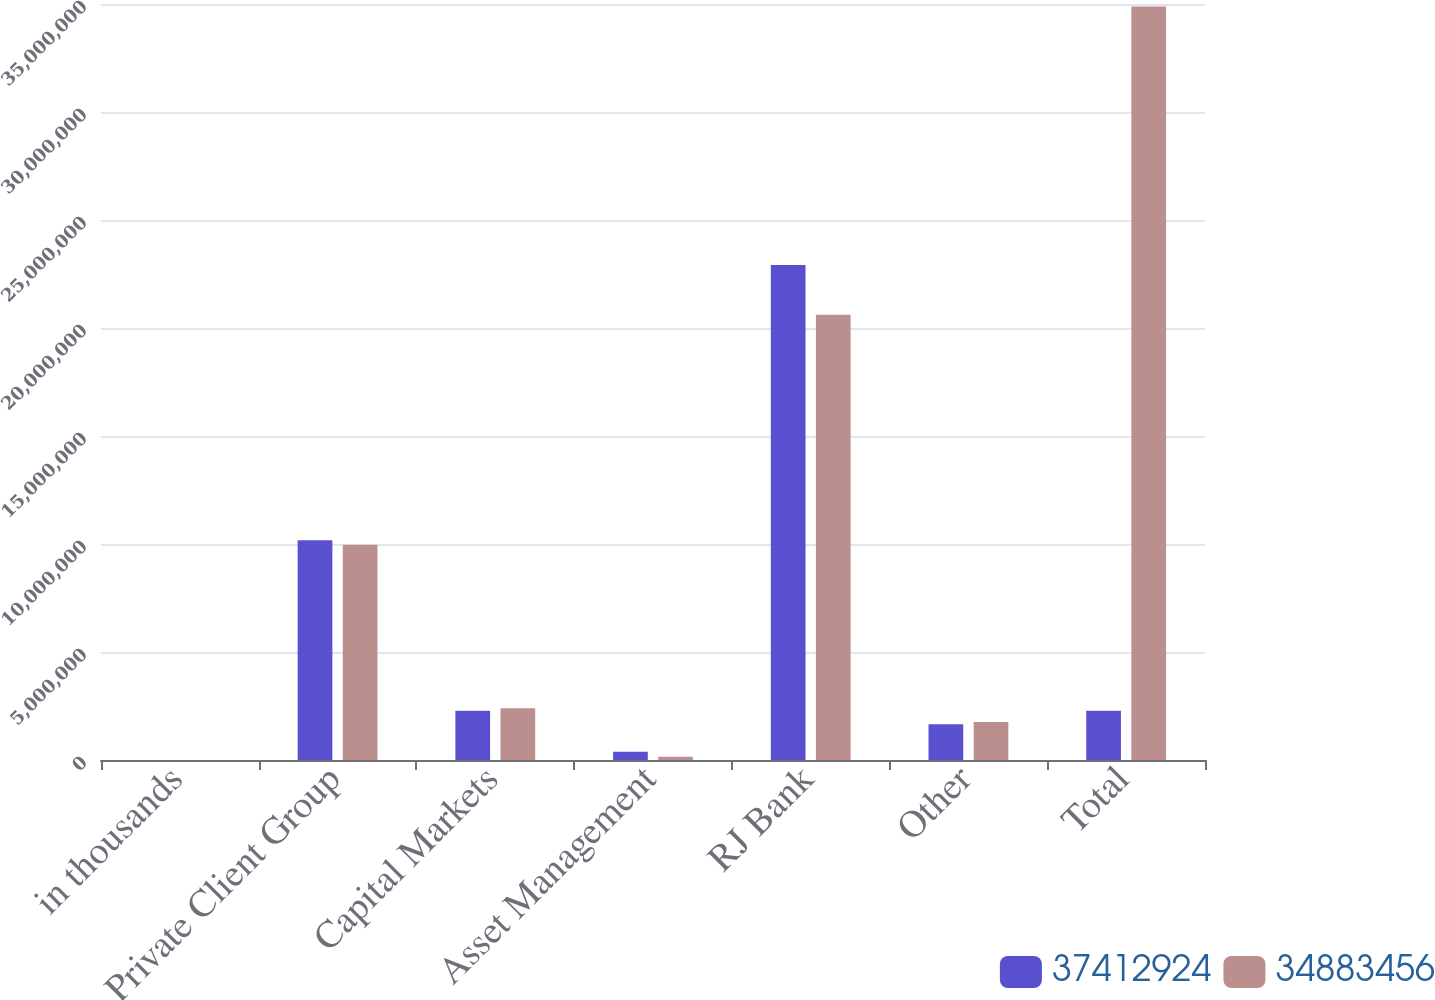Convert chart. <chart><loc_0><loc_0><loc_500><loc_500><stacked_bar_chart><ecel><fcel>in thousands<fcel>Private Client Group<fcel>Capital Markets<fcel>Asset Management<fcel>RJ Bank<fcel>Other<fcel>Total<nl><fcel>3.74129e+07<fcel>2018<fcel>1.01732e+07<fcel>2.27898e+06<fcel>386810<fcel>2.29224e+07<fcel>1.6516e+06<fcel>2.27898e+06<nl><fcel>3.48835e+07<fcel>2017<fcel>9.96732e+06<fcel>2.39603e+06<fcel>151111<fcel>2.06119e+07<fcel>1.75709e+06<fcel>3.48835e+07<nl></chart> 